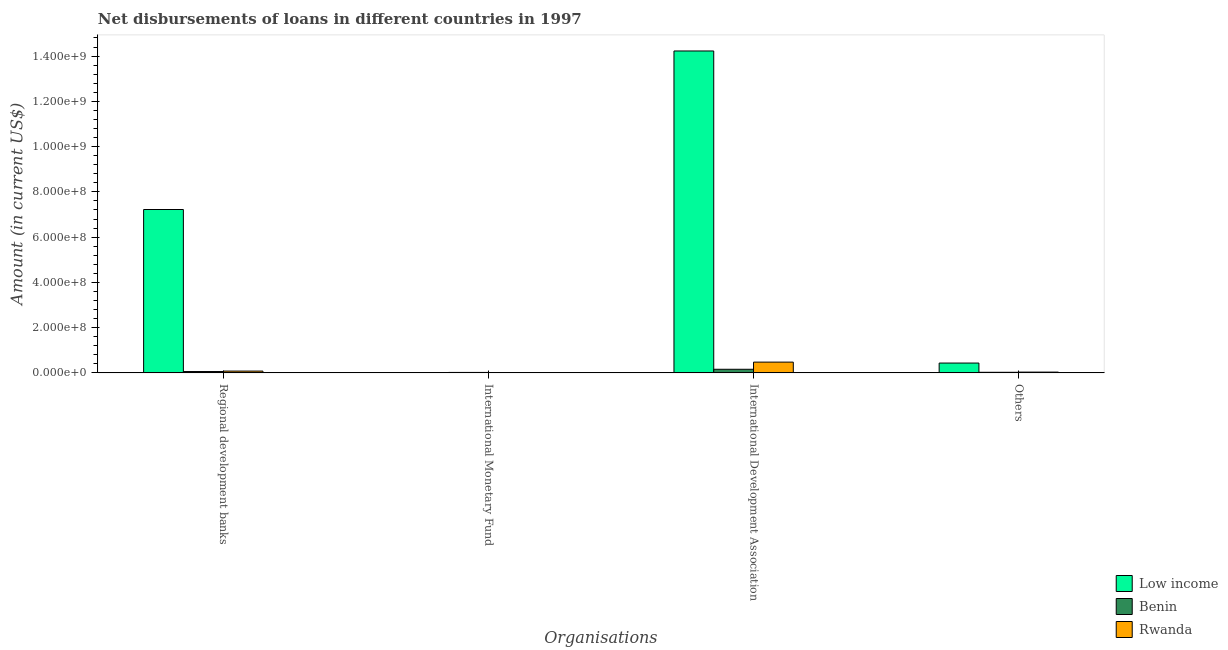Are the number of bars on each tick of the X-axis equal?
Keep it short and to the point. No. How many bars are there on the 2nd tick from the left?
Keep it short and to the point. 1. What is the label of the 1st group of bars from the left?
Provide a succinct answer. Regional development banks. What is the amount of loan disimbursed by regional development banks in Benin?
Give a very brief answer. 5.86e+06. Across all countries, what is the maximum amount of loan disimbursed by regional development banks?
Keep it short and to the point. 7.22e+08. Across all countries, what is the minimum amount of loan disimbursed by international development association?
Your answer should be compact. 1.59e+07. What is the total amount of loan disimbursed by international monetary fund in the graph?
Offer a very short reply. 1.93e+06. What is the difference between the amount of loan disimbursed by international development association in Benin and that in Rwanda?
Your response must be concise. -3.16e+07. What is the difference between the amount of loan disimbursed by international monetary fund in Rwanda and the amount of loan disimbursed by other organisations in Benin?
Your answer should be very brief. -2.57e+06. What is the average amount of loan disimbursed by international development association per country?
Ensure brevity in your answer.  4.95e+08. What is the difference between the amount of loan disimbursed by other organisations and amount of loan disimbursed by international development association in Rwanda?
Your response must be concise. -4.41e+07. What is the ratio of the amount of loan disimbursed by other organisations in Rwanda to that in Benin?
Offer a very short reply. 1.33. Is the difference between the amount of loan disimbursed by international development association in Benin and Low income greater than the difference between the amount of loan disimbursed by other organisations in Benin and Low income?
Keep it short and to the point. No. What is the difference between the highest and the second highest amount of loan disimbursed by international development association?
Your response must be concise. 1.38e+09. What is the difference between the highest and the lowest amount of loan disimbursed by international development association?
Provide a short and direct response. 1.41e+09. Is the sum of the amount of loan disimbursed by international development association in Low income and Rwanda greater than the maximum amount of loan disimbursed by international monetary fund across all countries?
Keep it short and to the point. Yes. Is it the case that in every country, the sum of the amount of loan disimbursed by regional development banks and amount of loan disimbursed by international monetary fund is greater than the sum of amount of loan disimbursed by international development association and amount of loan disimbursed by other organisations?
Offer a very short reply. No. Is it the case that in every country, the sum of the amount of loan disimbursed by regional development banks and amount of loan disimbursed by international monetary fund is greater than the amount of loan disimbursed by international development association?
Provide a succinct answer. No. How many bars are there?
Offer a very short reply. 10. Are all the bars in the graph horizontal?
Provide a succinct answer. No. How many countries are there in the graph?
Your response must be concise. 3. What is the difference between two consecutive major ticks on the Y-axis?
Give a very brief answer. 2.00e+08. How many legend labels are there?
Provide a short and direct response. 3. What is the title of the graph?
Your answer should be very brief. Net disbursements of loans in different countries in 1997. Does "Rwanda" appear as one of the legend labels in the graph?
Provide a short and direct response. Yes. What is the label or title of the X-axis?
Offer a terse response. Organisations. What is the Amount (in current US$) of Low income in Regional development banks?
Ensure brevity in your answer.  7.22e+08. What is the Amount (in current US$) in Benin in Regional development banks?
Offer a terse response. 5.86e+06. What is the Amount (in current US$) of Rwanda in Regional development banks?
Offer a terse response. 7.89e+06. What is the Amount (in current US$) in Benin in International Monetary Fund?
Give a very brief answer. 1.93e+06. What is the Amount (in current US$) of Rwanda in International Monetary Fund?
Your answer should be very brief. 0. What is the Amount (in current US$) in Low income in International Development Association?
Make the answer very short. 1.42e+09. What is the Amount (in current US$) of Benin in International Development Association?
Ensure brevity in your answer.  1.59e+07. What is the Amount (in current US$) of Rwanda in International Development Association?
Make the answer very short. 4.75e+07. What is the Amount (in current US$) of Low income in Others?
Ensure brevity in your answer.  4.34e+07. What is the Amount (in current US$) in Benin in Others?
Provide a short and direct response. 2.57e+06. What is the Amount (in current US$) in Rwanda in Others?
Ensure brevity in your answer.  3.41e+06. Across all Organisations, what is the maximum Amount (in current US$) in Low income?
Your answer should be very brief. 1.42e+09. Across all Organisations, what is the maximum Amount (in current US$) of Benin?
Offer a terse response. 1.59e+07. Across all Organisations, what is the maximum Amount (in current US$) of Rwanda?
Give a very brief answer. 4.75e+07. Across all Organisations, what is the minimum Amount (in current US$) in Benin?
Your answer should be very brief. 1.93e+06. What is the total Amount (in current US$) of Low income in the graph?
Keep it short and to the point. 2.19e+09. What is the total Amount (in current US$) in Benin in the graph?
Ensure brevity in your answer.  2.62e+07. What is the total Amount (in current US$) of Rwanda in the graph?
Make the answer very short. 5.88e+07. What is the difference between the Amount (in current US$) in Benin in Regional development banks and that in International Monetary Fund?
Offer a terse response. 3.93e+06. What is the difference between the Amount (in current US$) in Low income in Regional development banks and that in International Development Association?
Ensure brevity in your answer.  -7.01e+08. What is the difference between the Amount (in current US$) in Benin in Regional development banks and that in International Development Association?
Ensure brevity in your answer.  -1.00e+07. What is the difference between the Amount (in current US$) in Rwanda in Regional development banks and that in International Development Association?
Your answer should be compact. -3.96e+07. What is the difference between the Amount (in current US$) of Low income in Regional development banks and that in Others?
Provide a short and direct response. 6.79e+08. What is the difference between the Amount (in current US$) of Benin in Regional development banks and that in Others?
Provide a short and direct response. 3.29e+06. What is the difference between the Amount (in current US$) of Rwanda in Regional development banks and that in Others?
Provide a succinct answer. 4.48e+06. What is the difference between the Amount (in current US$) in Benin in International Monetary Fund and that in International Development Association?
Offer a terse response. -1.40e+07. What is the difference between the Amount (in current US$) of Benin in International Monetary Fund and that in Others?
Give a very brief answer. -6.43e+05. What is the difference between the Amount (in current US$) of Low income in International Development Association and that in Others?
Give a very brief answer. 1.38e+09. What is the difference between the Amount (in current US$) of Benin in International Development Association and that in Others?
Your answer should be compact. 1.33e+07. What is the difference between the Amount (in current US$) of Rwanda in International Development Association and that in Others?
Your answer should be compact. 4.41e+07. What is the difference between the Amount (in current US$) of Low income in Regional development banks and the Amount (in current US$) of Benin in International Monetary Fund?
Provide a succinct answer. 7.20e+08. What is the difference between the Amount (in current US$) of Low income in Regional development banks and the Amount (in current US$) of Benin in International Development Association?
Offer a terse response. 7.06e+08. What is the difference between the Amount (in current US$) of Low income in Regional development banks and the Amount (in current US$) of Rwanda in International Development Association?
Keep it short and to the point. 6.74e+08. What is the difference between the Amount (in current US$) of Benin in Regional development banks and the Amount (in current US$) of Rwanda in International Development Association?
Offer a terse response. -4.17e+07. What is the difference between the Amount (in current US$) of Low income in Regional development banks and the Amount (in current US$) of Benin in Others?
Offer a terse response. 7.19e+08. What is the difference between the Amount (in current US$) in Low income in Regional development banks and the Amount (in current US$) in Rwanda in Others?
Your response must be concise. 7.19e+08. What is the difference between the Amount (in current US$) of Benin in Regional development banks and the Amount (in current US$) of Rwanda in Others?
Keep it short and to the point. 2.45e+06. What is the difference between the Amount (in current US$) of Benin in International Monetary Fund and the Amount (in current US$) of Rwanda in International Development Association?
Provide a succinct answer. -4.56e+07. What is the difference between the Amount (in current US$) in Benin in International Monetary Fund and the Amount (in current US$) in Rwanda in Others?
Your response must be concise. -1.48e+06. What is the difference between the Amount (in current US$) in Low income in International Development Association and the Amount (in current US$) in Benin in Others?
Provide a succinct answer. 1.42e+09. What is the difference between the Amount (in current US$) in Low income in International Development Association and the Amount (in current US$) in Rwanda in Others?
Your response must be concise. 1.42e+09. What is the difference between the Amount (in current US$) in Benin in International Development Association and the Amount (in current US$) in Rwanda in Others?
Offer a terse response. 1.25e+07. What is the average Amount (in current US$) of Low income per Organisations?
Your response must be concise. 5.47e+08. What is the average Amount (in current US$) in Benin per Organisations?
Give a very brief answer. 6.56e+06. What is the average Amount (in current US$) of Rwanda per Organisations?
Provide a succinct answer. 1.47e+07. What is the difference between the Amount (in current US$) of Low income and Amount (in current US$) of Benin in Regional development banks?
Your answer should be very brief. 7.16e+08. What is the difference between the Amount (in current US$) of Low income and Amount (in current US$) of Rwanda in Regional development banks?
Your response must be concise. 7.14e+08. What is the difference between the Amount (in current US$) in Benin and Amount (in current US$) in Rwanda in Regional development banks?
Offer a terse response. -2.03e+06. What is the difference between the Amount (in current US$) in Low income and Amount (in current US$) in Benin in International Development Association?
Ensure brevity in your answer.  1.41e+09. What is the difference between the Amount (in current US$) in Low income and Amount (in current US$) in Rwanda in International Development Association?
Your answer should be very brief. 1.38e+09. What is the difference between the Amount (in current US$) of Benin and Amount (in current US$) of Rwanda in International Development Association?
Make the answer very short. -3.16e+07. What is the difference between the Amount (in current US$) in Low income and Amount (in current US$) in Benin in Others?
Provide a short and direct response. 4.08e+07. What is the difference between the Amount (in current US$) of Low income and Amount (in current US$) of Rwanda in Others?
Your response must be concise. 4.00e+07. What is the difference between the Amount (in current US$) of Benin and Amount (in current US$) of Rwanda in Others?
Make the answer very short. -8.36e+05. What is the ratio of the Amount (in current US$) of Benin in Regional development banks to that in International Monetary Fund?
Offer a very short reply. 3.04. What is the ratio of the Amount (in current US$) in Low income in Regional development banks to that in International Development Association?
Your answer should be compact. 0.51. What is the ratio of the Amount (in current US$) of Benin in Regional development banks to that in International Development Association?
Offer a very short reply. 0.37. What is the ratio of the Amount (in current US$) in Rwanda in Regional development banks to that in International Development Association?
Make the answer very short. 0.17. What is the ratio of the Amount (in current US$) in Low income in Regional development banks to that in Others?
Your answer should be very brief. 16.64. What is the ratio of the Amount (in current US$) in Benin in Regional development banks to that in Others?
Your response must be concise. 2.28. What is the ratio of the Amount (in current US$) in Rwanda in Regional development banks to that in Others?
Your answer should be very brief. 2.32. What is the ratio of the Amount (in current US$) of Benin in International Monetary Fund to that in International Development Association?
Give a very brief answer. 0.12. What is the ratio of the Amount (in current US$) in Benin in International Monetary Fund to that in Others?
Ensure brevity in your answer.  0.75. What is the ratio of the Amount (in current US$) in Low income in International Development Association to that in Others?
Make the answer very short. 32.78. What is the ratio of the Amount (in current US$) of Benin in International Development Association to that in Others?
Provide a succinct answer. 6.18. What is the ratio of the Amount (in current US$) in Rwanda in International Development Association to that in Others?
Offer a very short reply. 13.95. What is the difference between the highest and the second highest Amount (in current US$) in Low income?
Ensure brevity in your answer.  7.01e+08. What is the difference between the highest and the second highest Amount (in current US$) of Benin?
Offer a terse response. 1.00e+07. What is the difference between the highest and the second highest Amount (in current US$) of Rwanda?
Your response must be concise. 3.96e+07. What is the difference between the highest and the lowest Amount (in current US$) in Low income?
Your answer should be very brief. 1.42e+09. What is the difference between the highest and the lowest Amount (in current US$) of Benin?
Provide a succinct answer. 1.40e+07. What is the difference between the highest and the lowest Amount (in current US$) of Rwanda?
Provide a succinct answer. 4.75e+07. 